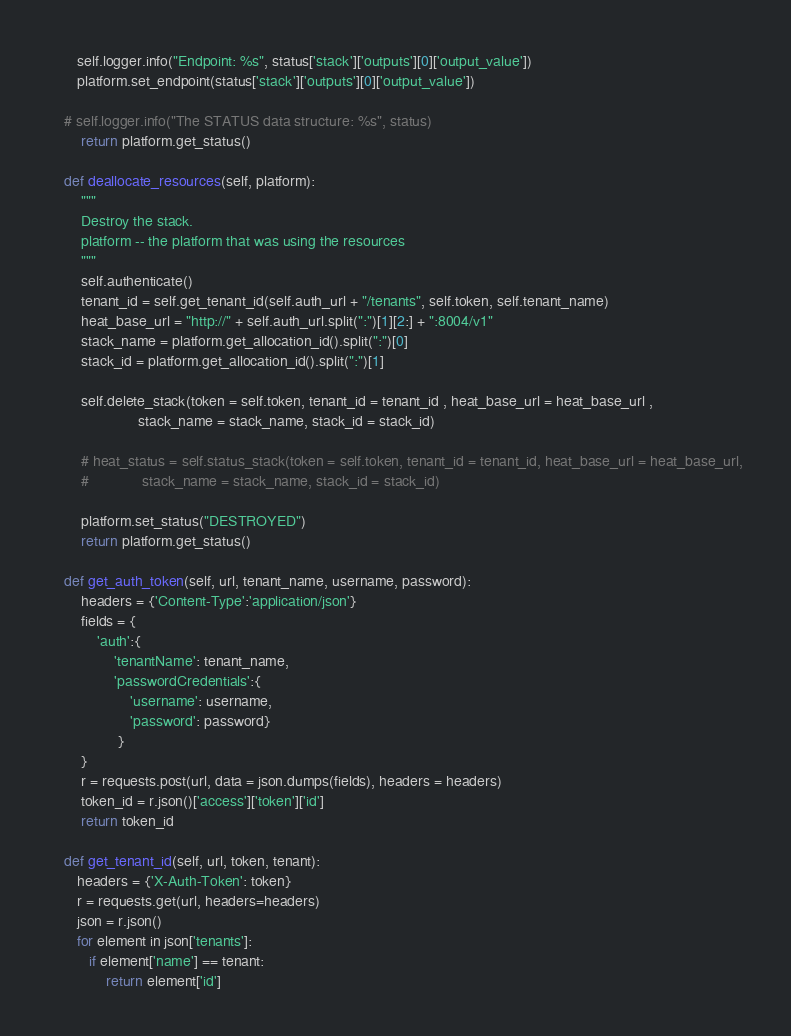Convert code to text. <code><loc_0><loc_0><loc_500><loc_500><_Python_>	   self.logger.info("Endpoint: %s", status['stack']['outputs'][0]['output_value'])
	   platform.set_endpoint(status['stack']['outputs'][0]['output_value'])

	# self.logger.info("The STATUS data structure: %s", status)
        return platform.get_status()

    def deallocate_resources(self, platform):
        """
        Destroy the stack.
        platform -- the platform that was using the resources
        """
        self.authenticate()
        tenant_id = self.get_tenant_id(self.auth_url + "/tenants", self.token, self.tenant_name)
        heat_base_url = "http://" + self.auth_url.split(":")[1][2:] + ":8004/v1"
        stack_name = platform.get_allocation_id().split(":")[0]
        stack_id = platform.get_allocation_id().split(":")[1]

        self.delete_stack(token = self.token, tenant_id = tenant_id , heat_base_url = heat_base_url ,
                      stack_name = stack_name, stack_id = stack_id)

        # heat_status = self.status_stack(token = self.token, tenant_id = tenant_id, heat_base_url = heat_base_url,
        #             stack_name = stack_name, stack_id = stack_id)

        platform.set_status("DESTROYED")
        return platform.get_status()

    def get_auth_token(self, url, tenant_name, username, password):
        headers = {'Content-Type':'application/json'}
        fields = {
            'auth':{
                'tenantName': tenant_name,
                'passwordCredentials':{
                    'username': username,
                    'password': password}
                 }
        }
        r = requests.post(url, data = json.dumps(fields), headers = headers)
        token_id = r.json()['access']['token']['id']
        return token_id

    def get_tenant_id(self, url, token, tenant):
       headers = {'X-Auth-Token': token}
       r = requests.get(url, headers=headers)
       json = r.json()
       for element in json['tenants']:
          if element['name'] == tenant:
              return element['id']
</code> 